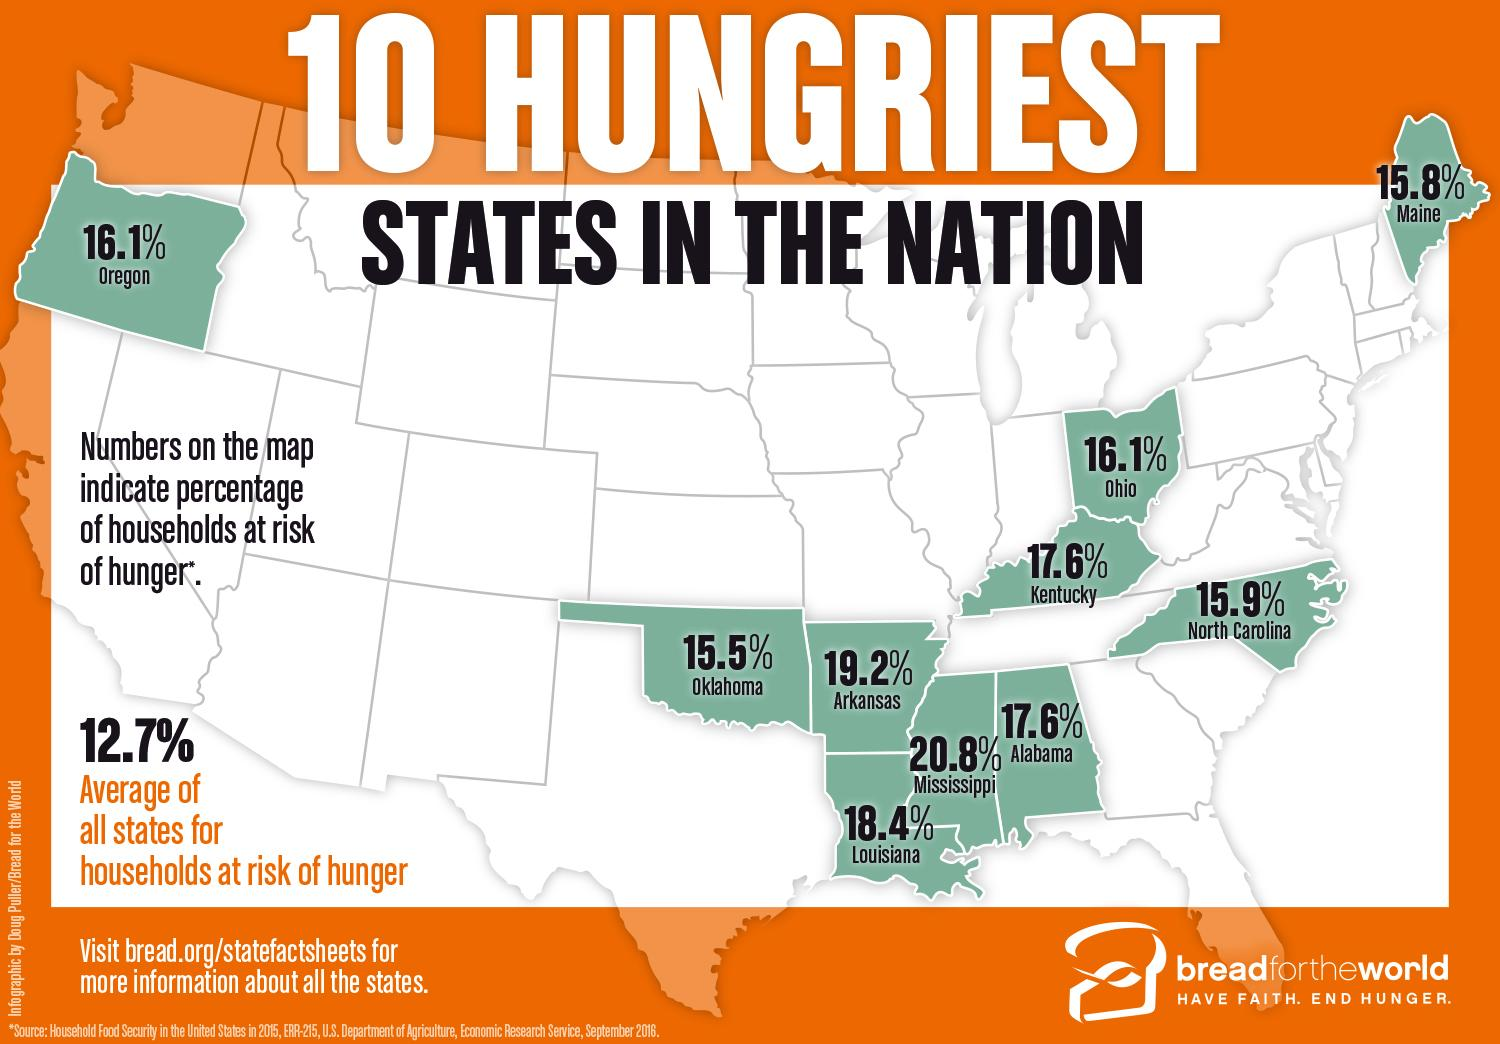Give some essential details in this illustration. The percentage of households at risk of hunger in Kentucky is significantly higher than in Ohio, with a difference of 1.5%. A recent study has revealed that a total of 34.7% of households in Oklahoma and Arkansas are at risk of hunger. According to the latest statistics, the state of Arkansas has the second highest percentage of households at risk of hunger, representing a concerning issue that requires immediate attention and action. 